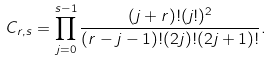Convert formula to latex. <formula><loc_0><loc_0><loc_500><loc_500>C _ { r , s } = \prod _ { j = 0 } ^ { s - 1 } \frac { ( j + r ) ! ( j ! ) ^ { 2 } } { ( r - j - 1 ) ! ( 2 j ) ! ( 2 j + 1 ) ! } .</formula> 